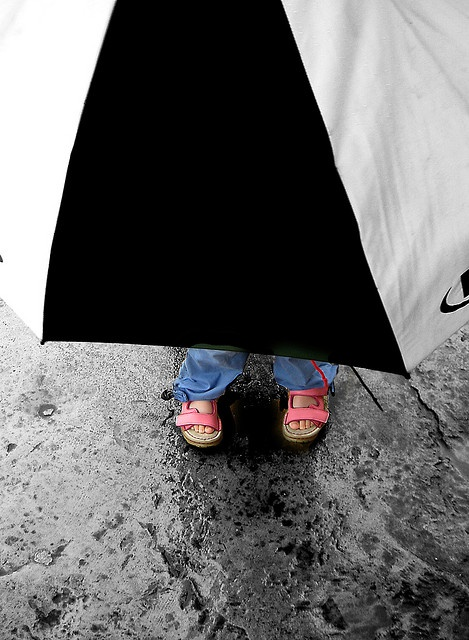Describe the objects in this image and their specific colors. I can see umbrella in white, black, lightgray, darkgray, and gray tones and people in white, gray, blue, and black tones in this image. 